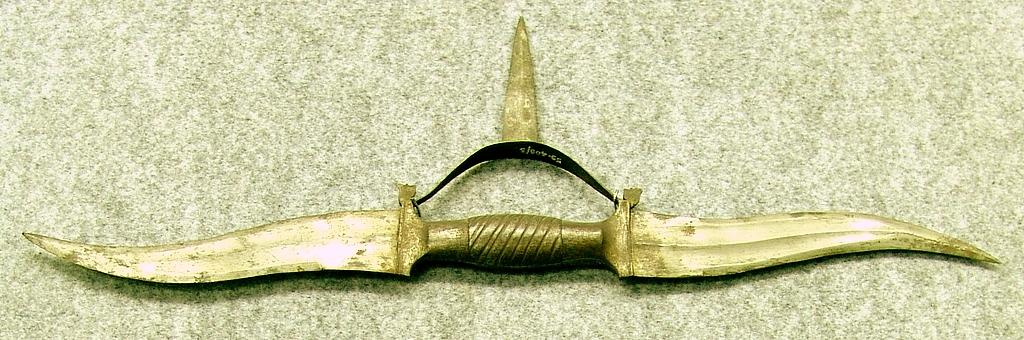What type of object is the main subject of the image? There is a golden color weapon in the image. Can you describe the location of the weapon in the image? The weapon is on a surface. What type of fruit is being cut on the patch in the image? There is no fruit or patch present in the image; it features a golden color weapon on a surface. 